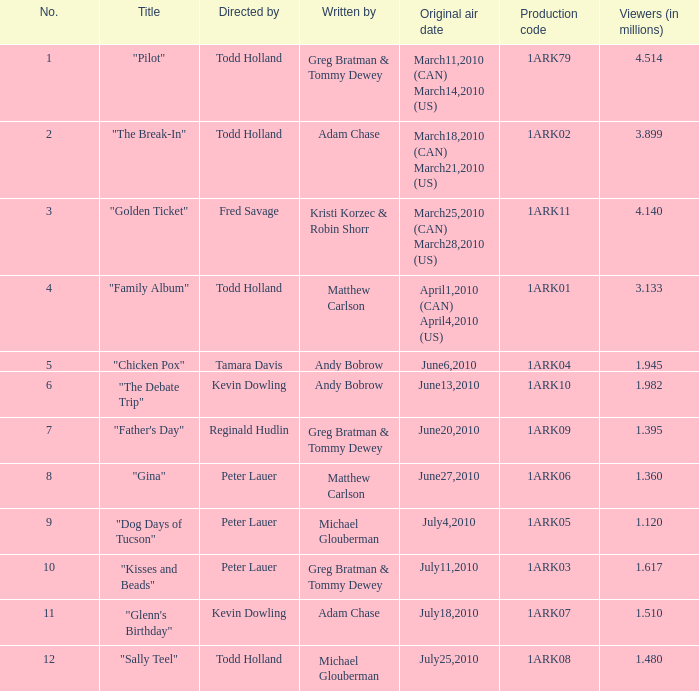Enumerate all directors from episodes with an audience of Tamara Davis. 